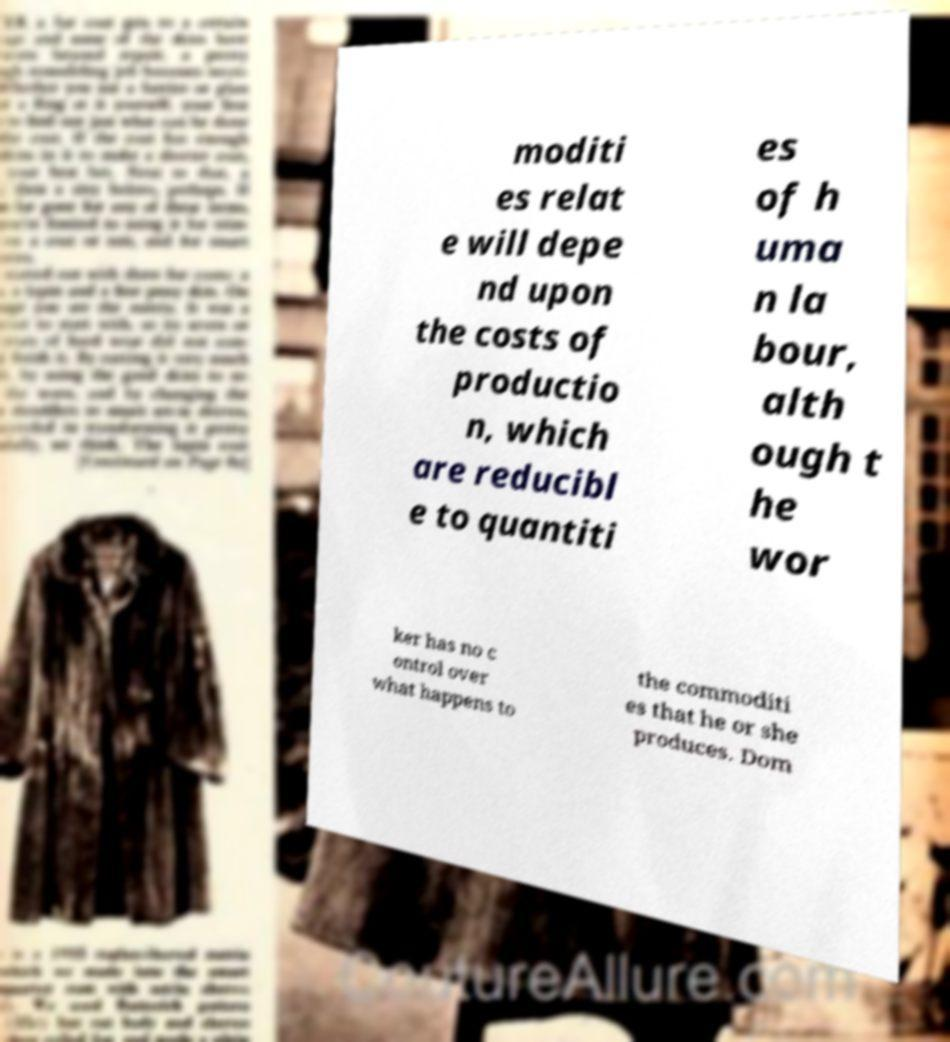Please identify and transcribe the text found in this image. moditi es relat e will depe nd upon the costs of productio n, which are reducibl e to quantiti es of h uma n la bour, alth ough t he wor ker has no c ontrol over what happens to the commoditi es that he or she produces. Dom 